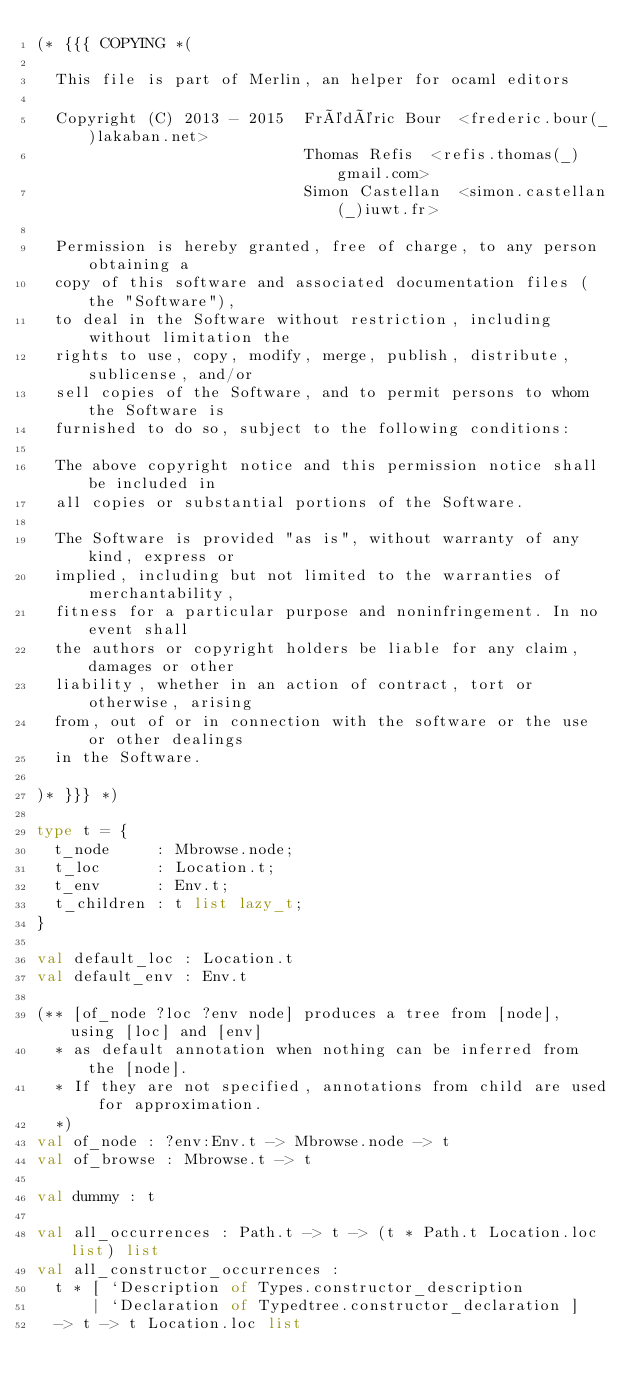Convert code to text. <code><loc_0><loc_0><loc_500><loc_500><_OCaml_>(* {{{ COPYING *(

  This file is part of Merlin, an helper for ocaml editors

  Copyright (C) 2013 - 2015  Frédéric Bour  <frederic.bour(_)lakaban.net>
                             Thomas Refis  <refis.thomas(_)gmail.com>
                             Simon Castellan  <simon.castellan(_)iuwt.fr>

  Permission is hereby granted, free of charge, to any person obtaining a
  copy of this software and associated documentation files (the "Software"),
  to deal in the Software without restriction, including without limitation the
  rights to use, copy, modify, merge, publish, distribute, sublicense, and/or
  sell copies of the Software, and to permit persons to whom the Software is
  furnished to do so, subject to the following conditions:

  The above copyright notice and this permission notice shall be included in
  all copies or substantial portions of the Software.

  The Software is provided "as is", without warranty of any kind, express or
  implied, including but not limited to the warranties of merchantability,
  fitness for a particular purpose and noninfringement. In no event shall
  the authors or copyright holders be liable for any claim, damages or other
  liability, whether in an action of contract, tort or otherwise, arising
  from, out of or in connection with the software or the use or other dealings
  in the Software.

)* }}} *)

type t = {
  t_node     : Mbrowse.node;
  t_loc      : Location.t;
  t_env      : Env.t;
  t_children : t list lazy_t;
}

val default_loc : Location.t
val default_env : Env.t

(** [of_node ?loc ?env node] produces a tree from [node], using [loc] and [env]
  * as default annotation when nothing can be inferred from the [node].
  * If they are not specified, annotations from child are used for approximation.
  *)
val of_node : ?env:Env.t -> Mbrowse.node -> t
val of_browse : Mbrowse.t -> t

val dummy : t

val all_occurrences : Path.t -> t -> (t * Path.t Location.loc list) list
val all_constructor_occurrences :
  t * [ `Description of Types.constructor_description
      | `Declaration of Typedtree.constructor_declaration ]
  -> t -> t Location.loc list
</code> 